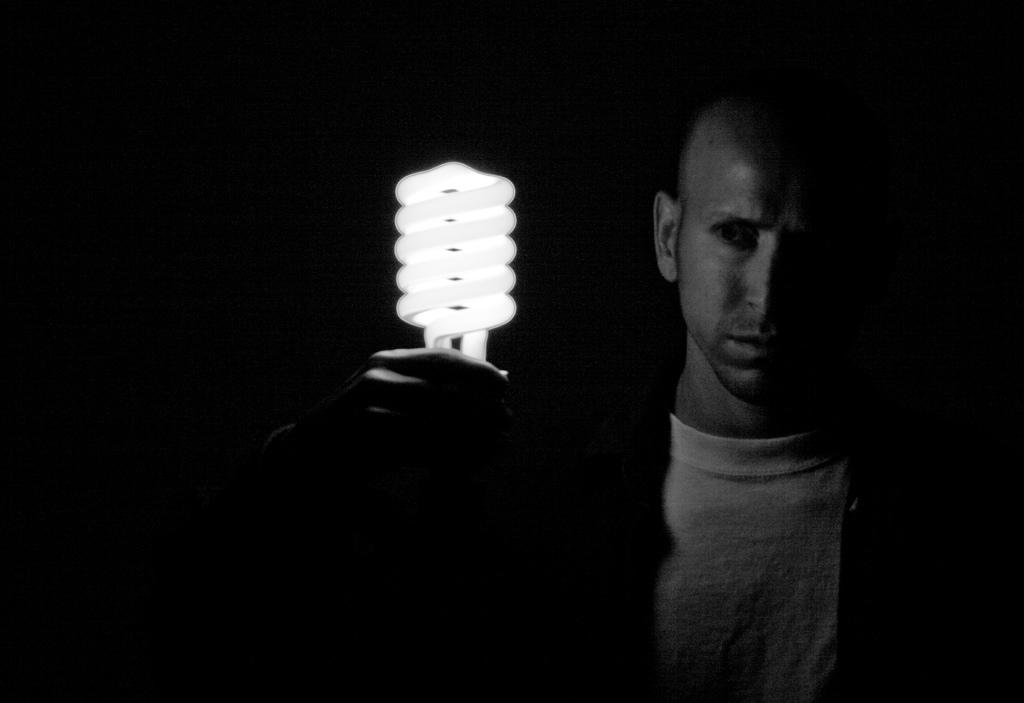Who is present in the image? There is a man in the image. What is the man holding in his hand? The man is holding a bulb in his hand. What type of collar is the man wearing in the image? There is no collar visible in the image, as the man is not wearing any clothing. What is the man doing with the twig in the image? There is no twig present in the image; the man is holding a bulb. 